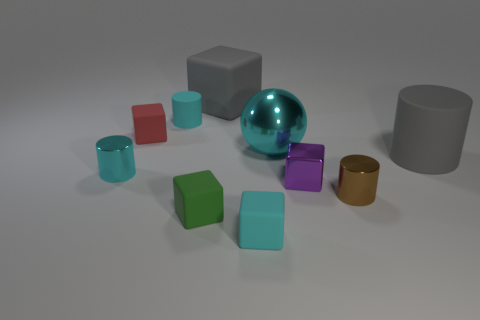How many cyan cylinders must be subtracted to get 1 cyan cylinders? 1 Subtract all large gray blocks. How many blocks are left? 4 Subtract 0 yellow cubes. How many objects are left? 10 Subtract all balls. How many objects are left? 9 Subtract 4 cylinders. How many cylinders are left? 0 Subtract all blue cubes. Subtract all green cylinders. How many cubes are left? 5 Subtract all purple cylinders. How many green balls are left? 0 Subtract all small red matte cubes. Subtract all small cyan cubes. How many objects are left? 8 Add 1 large gray objects. How many large gray objects are left? 3 Add 2 red rubber cylinders. How many red rubber cylinders exist? 2 